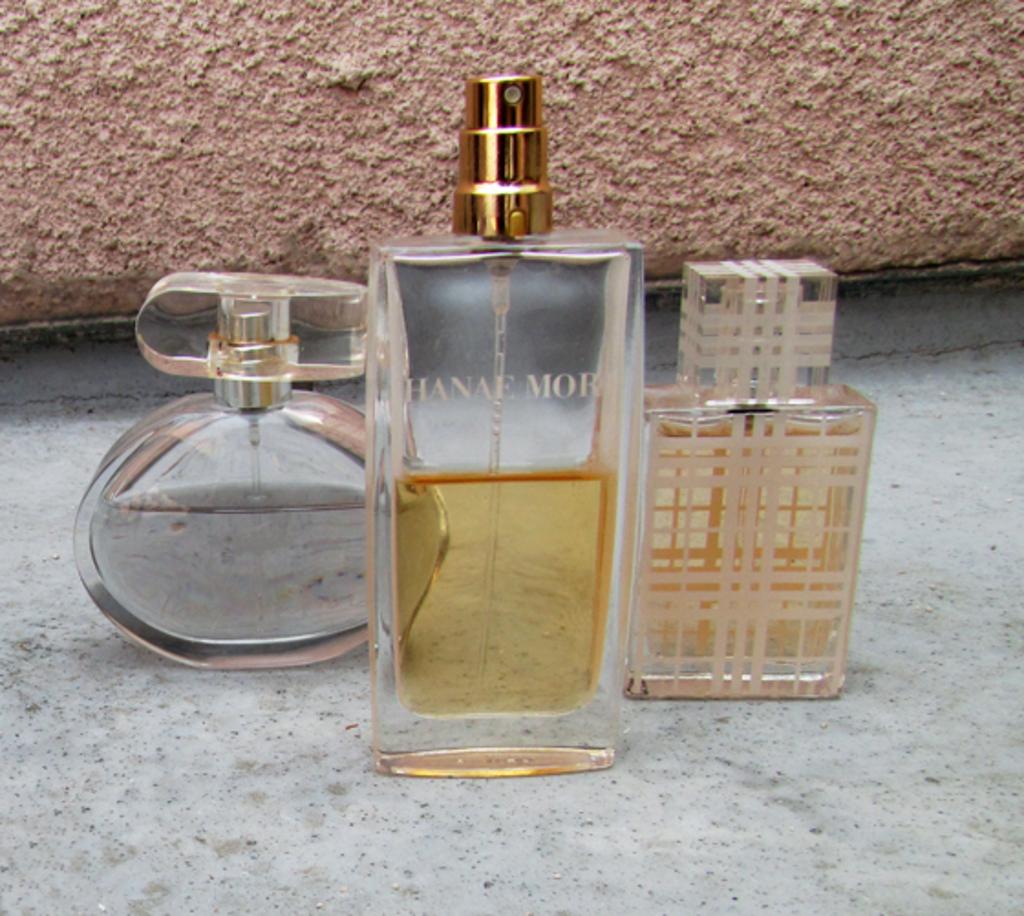Who makes the perfume in the middle?
Offer a very short reply. Hanae mor. 